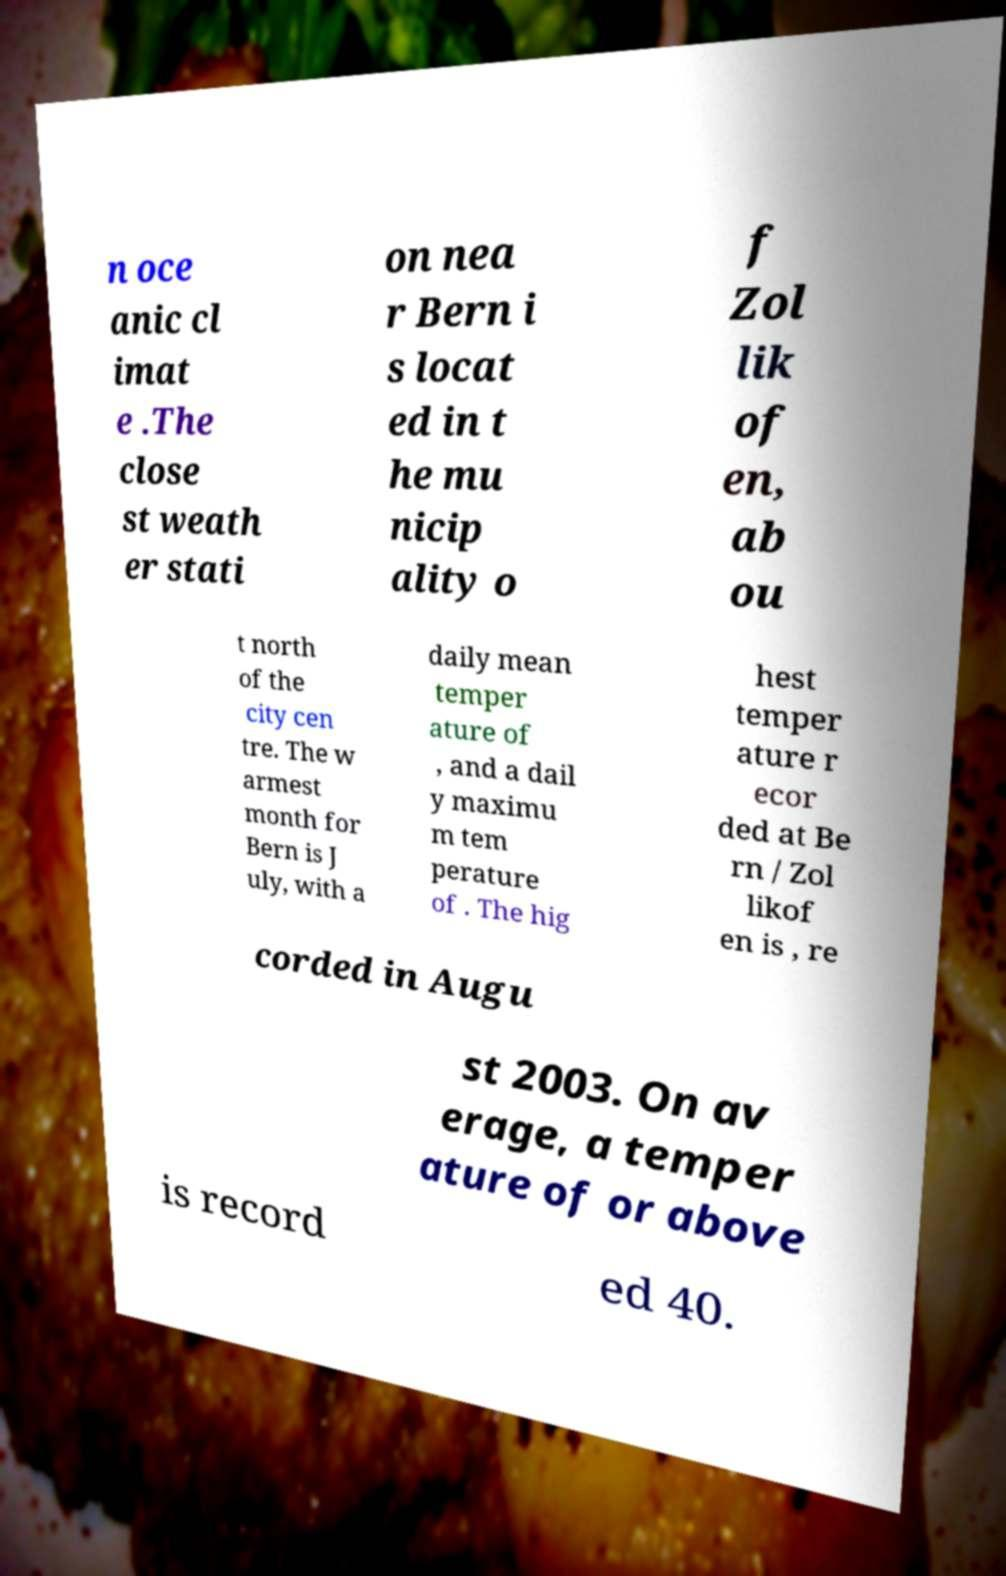Please identify and transcribe the text found in this image. n oce anic cl imat e .The close st weath er stati on nea r Bern i s locat ed in t he mu nicip ality o f Zol lik of en, ab ou t north of the city cen tre. The w armest month for Bern is J uly, with a daily mean temper ature of , and a dail y maximu m tem perature of . The hig hest temper ature r ecor ded at Be rn / Zol likof en is , re corded in Augu st 2003. On av erage, a temper ature of or above is record ed 40. 